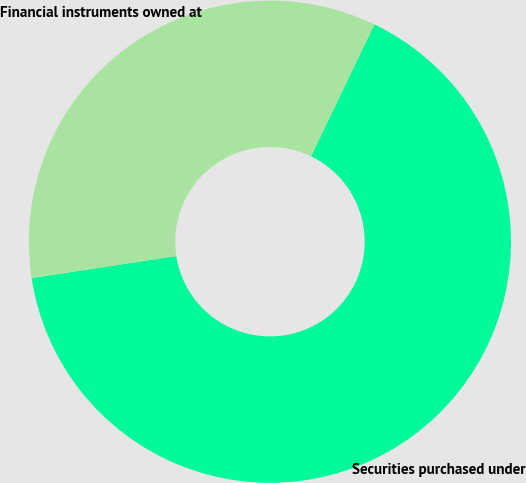<chart> <loc_0><loc_0><loc_500><loc_500><pie_chart><fcel>Securities purchased under<fcel>Financial instruments owned at<nl><fcel>65.46%<fcel>34.54%<nl></chart> 